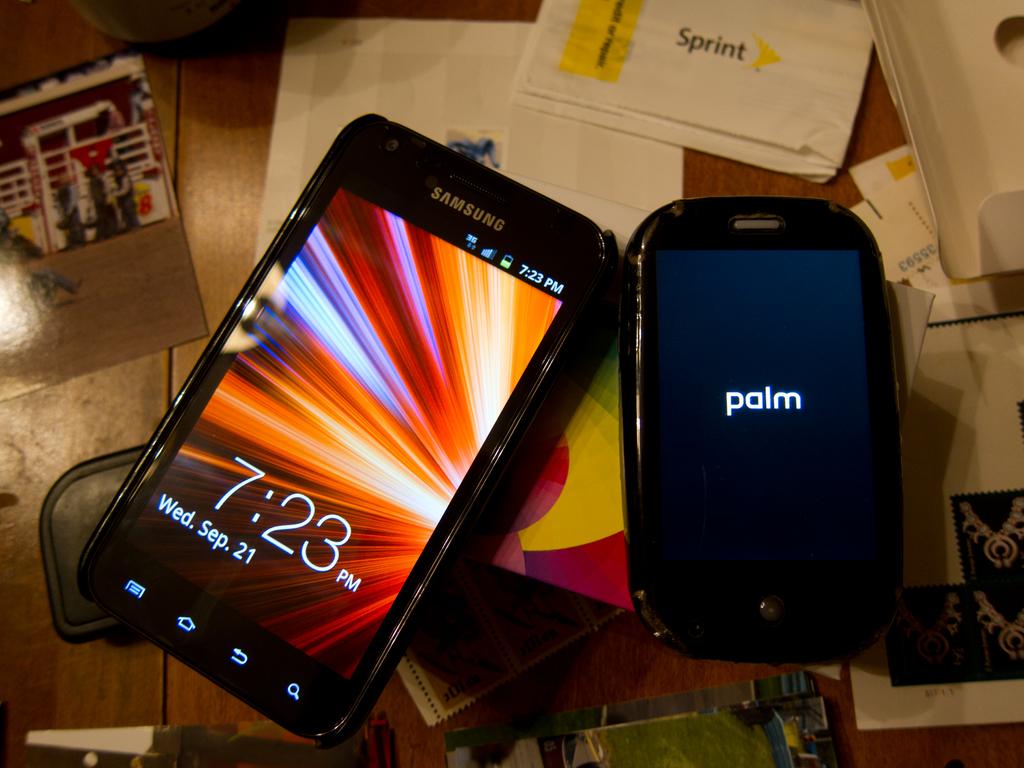What time is displayed on the cell phone?
Offer a very short reply. 7:23 pm. At time is it?
Your answer should be very brief. 7:23. 